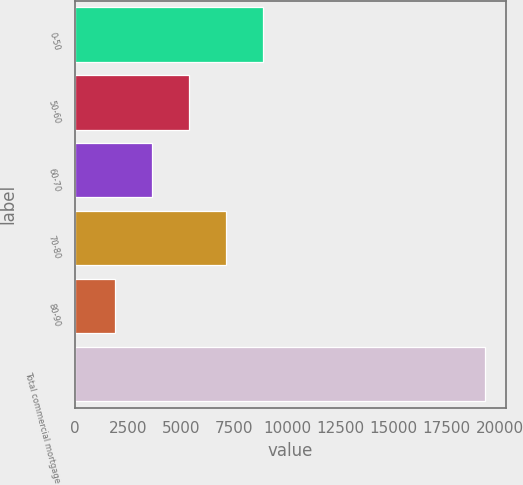Convert chart. <chart><loc_0><loc_0><loc_500><loc_500><bar_chart><fcel>0-50<fcel>50-60<fcel>60-70<fcel>70-80<fcel>80-90<fcel>Total commercial mortgage<nl><fcel>8876.6<fcel>5394.8<fcel>3653.9<fcel>7135.7<fcel>1913<fcel>19322<nl></chart> 